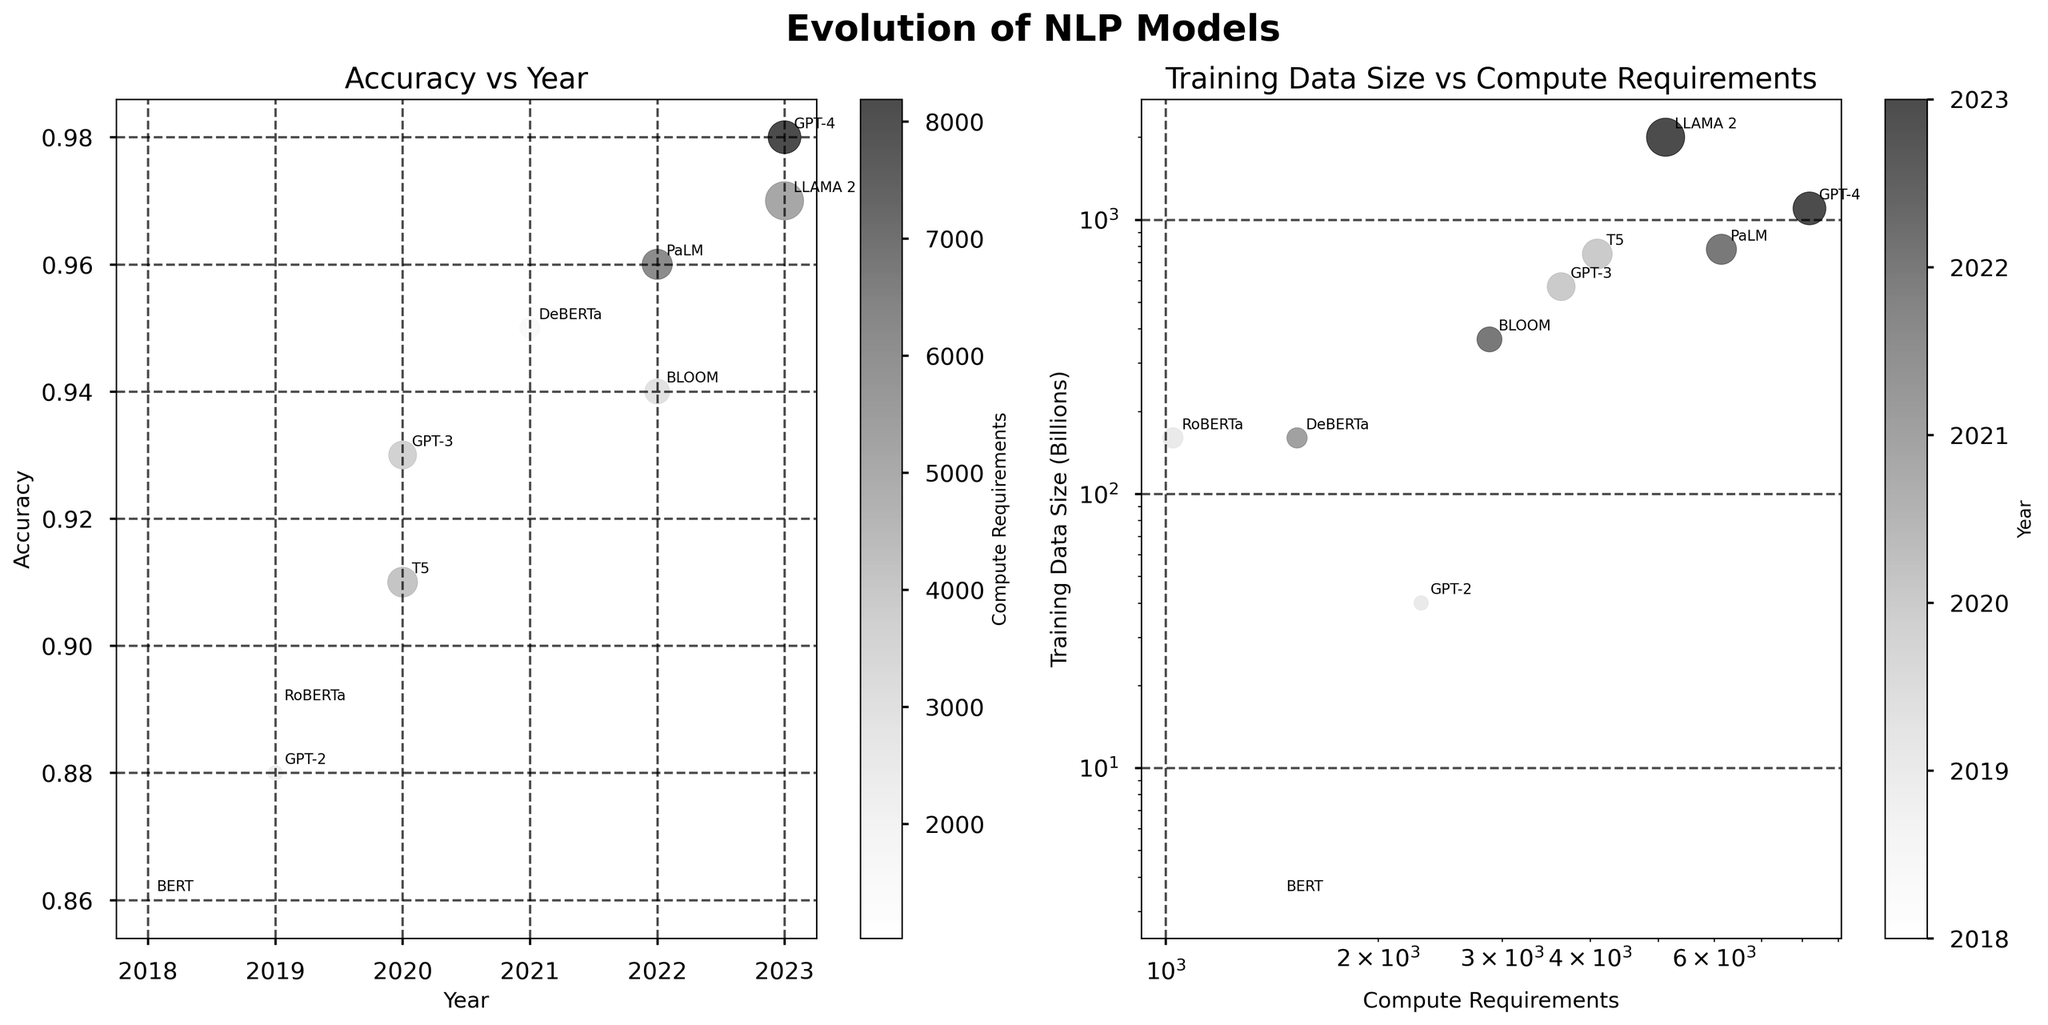What is the title of the figure? The title of the figure is located at the top center. It states 'Evolution of NLP Models'.
Answer: Evolution of NLP Models What does the x-axis represent in the first subplot? The x-axis in the first subplot is labeled 'Year'. It represents the years in which the models were released.
Answer: Year Which model has the highest accuracy? Look at the y-values in the first subplot, which represent accuracy. The highest point corresponds to GPT-4, which has an accuracy of 0.98.
Answer: GPT-4 What color scheme is used for the bubbles in the first subplot? The first subplot uses a grayscale color map for the bubbles, representing 'Compute Requirements'. The color shifts from lighter to darker shades of gray.
Answer: Grayscale Which model required the largest amount of training data, and how large was it? The second subplot shows 'Training Data Size' on the y-axis. LLAMA 2 is at the top, indicating it required the largest amount of training data, which is 2 trillion units.
Answer: LLAMA 2, 2 trillion units Which year had the most models released, and how many models were released that year? Count the data points along the x-axis of the first subplot. The year 2022 has the most points, indicating that two models (BLOOM and PaLM) were released that year.
Answer: 2022, 2 models What is the relationship between compute requirements and training data size for T5? Locate T5 in the second subplot. T5 has a high value for both compute requirements and training data size. Specifically, it has around 4096 units for compute requirements and 750 billion for training data size.
Answer: Both high Which model had a significant increase in accuracy compared to its predecessor in the same year? Compare accuracies for models released in the same year, such as 2019. RoBERTa has a higher accuracy (0.89) than GPT-2 (0.88) within the same year, but the increase is minor. Another noticeable increase can be seen from GPT-3 (0.93) compared to T5 (0.91) in 2020.
Answer: GPT-3 compared to T5 (2020) What is the general trend in compute requirements over the years? Observe the trend of bubble color shifting from lighter to darker shades of gray over the years in the first subplot. This indicates a general increase in compute requirements from 2018 to 2023.
Answer: Increasing trend Which model from 2023 has the largest training data size, and how much compute does it require? From 2023, compare GPT-4 and LLAMA 2 in the second subplot. LLAMA 2 has a larger training data size of 2 trillion units and requires 5120 units of compute.
Answer: LLAMA 2, 5120 units 